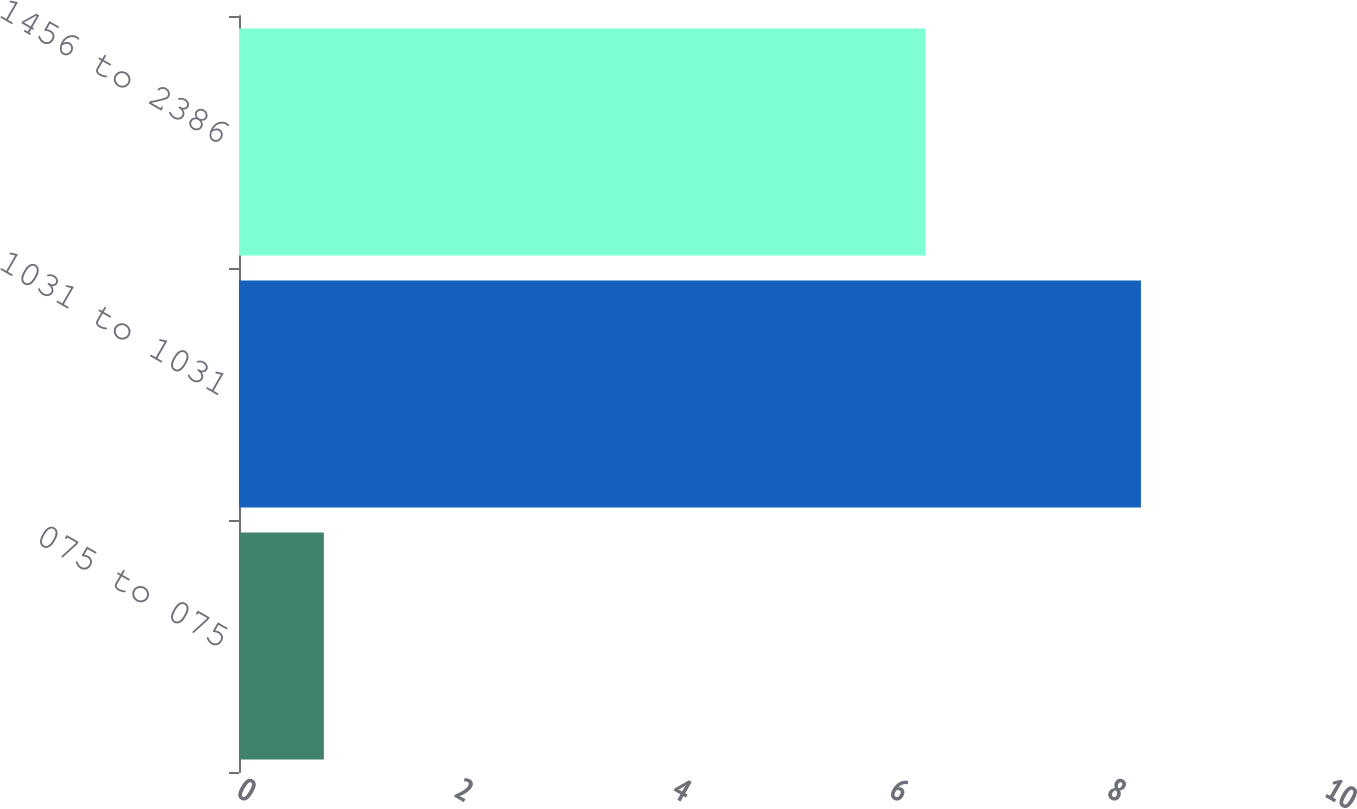<chart> <loc_0><loc_0><loc_500><loc_500><bar_chart><fcel>075 to 075<fcel>1031 to 1031<fcel>1456 to 2386<nl><fcel>0.78<fcel>8.29<fcel>6.31<nl></chart> 